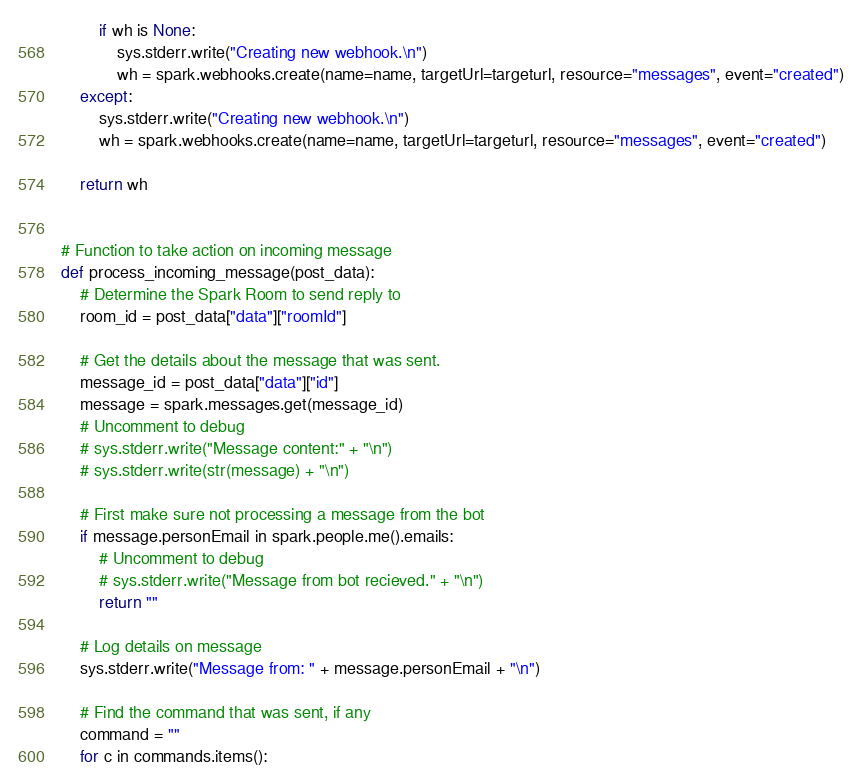Convert code to text. <code><loc_0><loc_0><loc_500><loc_500><_Python_>        if wh is None:
            sys.stderr.write("Creating new webhook.\n")
            wh = spark.webhooks.create(name=name, targetUrl=targeturl, resource="messages", event="created")
    except:
        sys.stderr.write("Creating new webhook.\n")
        wh = spark.webhooks.create(name=name, targetUrl=targeturl, resource="messages", event="created")

    return wh


# Function to take action on incoming message
def process_incoming_message(post_data):
    # Determine the Spark Room to send reply to
    room_id = post_data["data"]["roomId"]

    # Get the details about the message that was sent.
    message_id = post_data["data"]["id"]
    message = spark.messages.get(message_id)
    # Uncomment to debug
    # sys.stderr.write("Message content:" + "\n")
    # sys.stderr.write(str(message) + "\n")

    # First make sure not processing a message from the bot
    if message.personEmail in spark.people.me().emails:
        # Uncomment to debug
        # sys.stderr.write("Message from bot recieved." + "\n")
        return ""

    # Log details on message
    sys.stderr.write("Message from: " + message.personEmail + "\n")

    # Find the command that was sent, if any
    command = ""
    for c in commands.items():</code> 